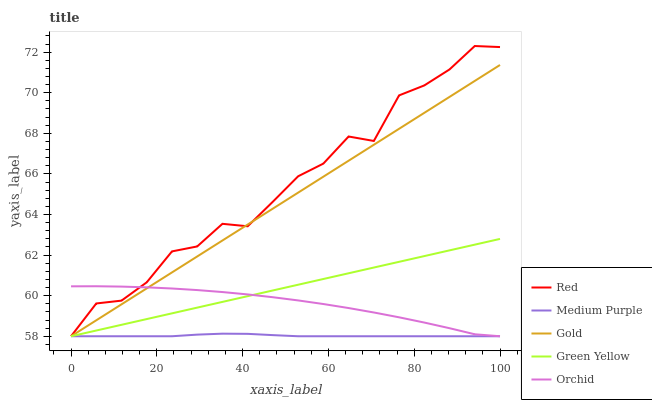Does Medium Purple have the minimum area under the curve?
Answer yes or no. Yes. Does Red have the maximum area under the curve?
Answer yes or no. Yes. Does Green Yellow have the minimum area under the curve?
Answer yes or no. No. Does Green Yellow have the maximum area under the curve?
Answer yes or no. No. Is Green Yellow the smoothest?
Answer yes or no. Yes. Is Red the roughest?
Answer yes or no. Yes. Is Gold the smoothest?
Answer yes or no. No. Is Gold the roughest?
Answer yes or no. No. Does Red have the highest value?
Answer yes or no. Yes. Does Green Yellow have the highest value?
Answer yes or no. No. Does Medium Purple intersect Gold?
Answer yes or no. Yes. Is Medium Purple less than Gold?
Answer yes or no. No. Is Medium Purple greater than Gold?
Answer yes or no. No. 